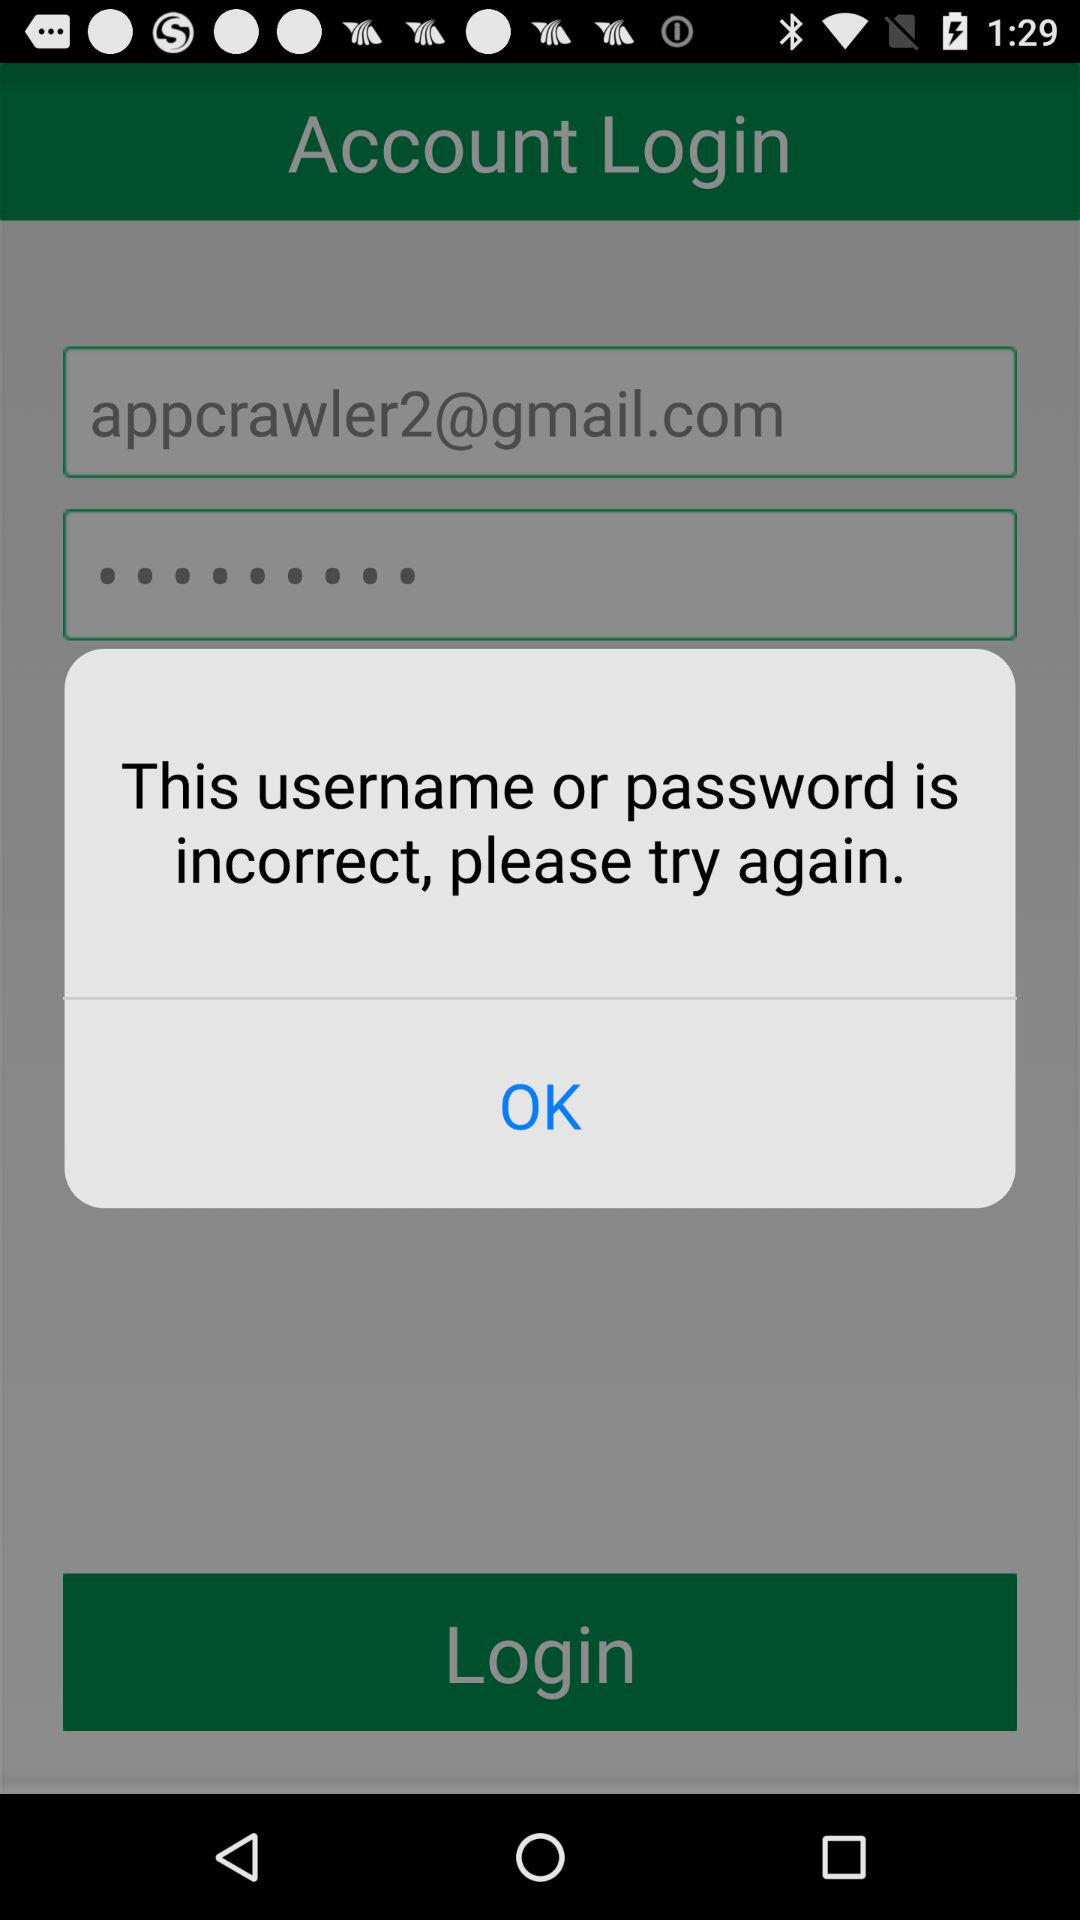What is the email address? The email address is appcrawler2@gmail.com. 